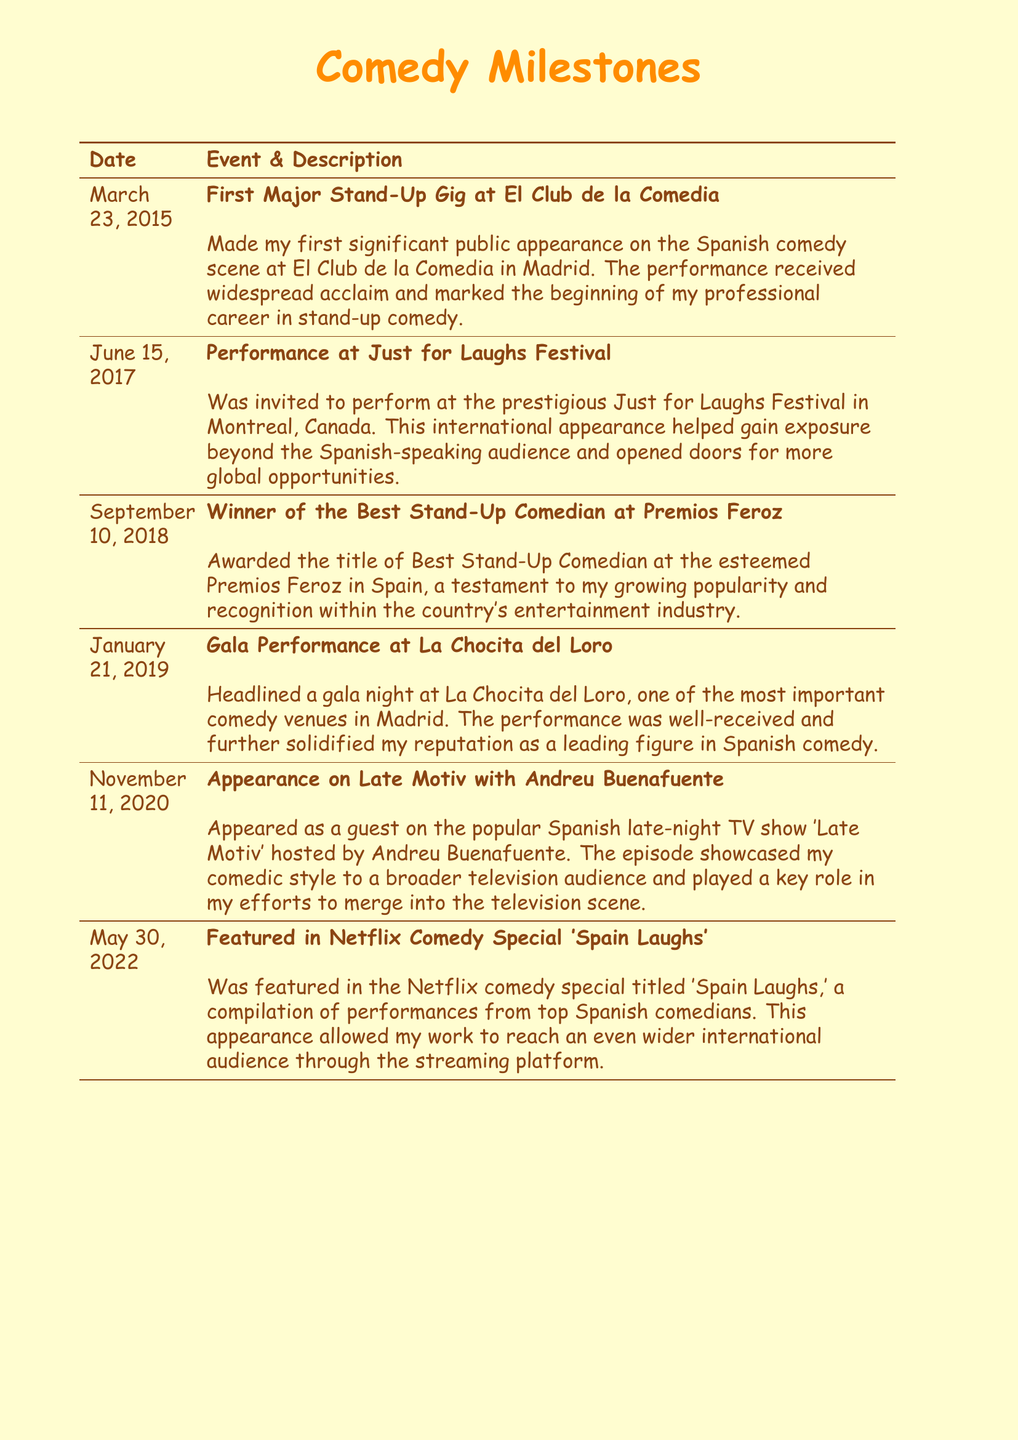What date was the first major stand-up gig? The date of the first major stand-up gig is specifically mentioned in the document as March 23, 2015.
Answer: March 23, 2015 What is the title of the award won in 2018? The award title is specifically stated in the document to be Best Stand-Up Comedian at Premios Feroz.
Answer: Best Stand-Up Comedian In which city did the performance at El Club de la Comedia take place? The document specifies that El Club de la Comedia is located in Madrid.
Answer: Madrid What festival did the comedian perform at in June 2017? The document mentions the Just for Laughs Festival as the festival in which the comedian participated in June 2017.
Answer: Just for Laughs Festival Which Netflix special featured the comedian in May 2022? The document specifically mentions the special as 'Spain Laughs.'
Answer: Spain Laughs How many major milestones are listed in the document? Reasoning through the document, six significant milestones are detailed, each with specific dates and descriptions.
Answer: Six What type of event was the gala performance at La Chocita del Loro? The document describes it as a gala night, indicating it was a prominent performance event.
Answer: Gala night Who hosted the Late Motiv show? The document states that the show 'Late Motiv' was hosted by Andreu Buenafuente.
Answer: Andreu Buenafuente 